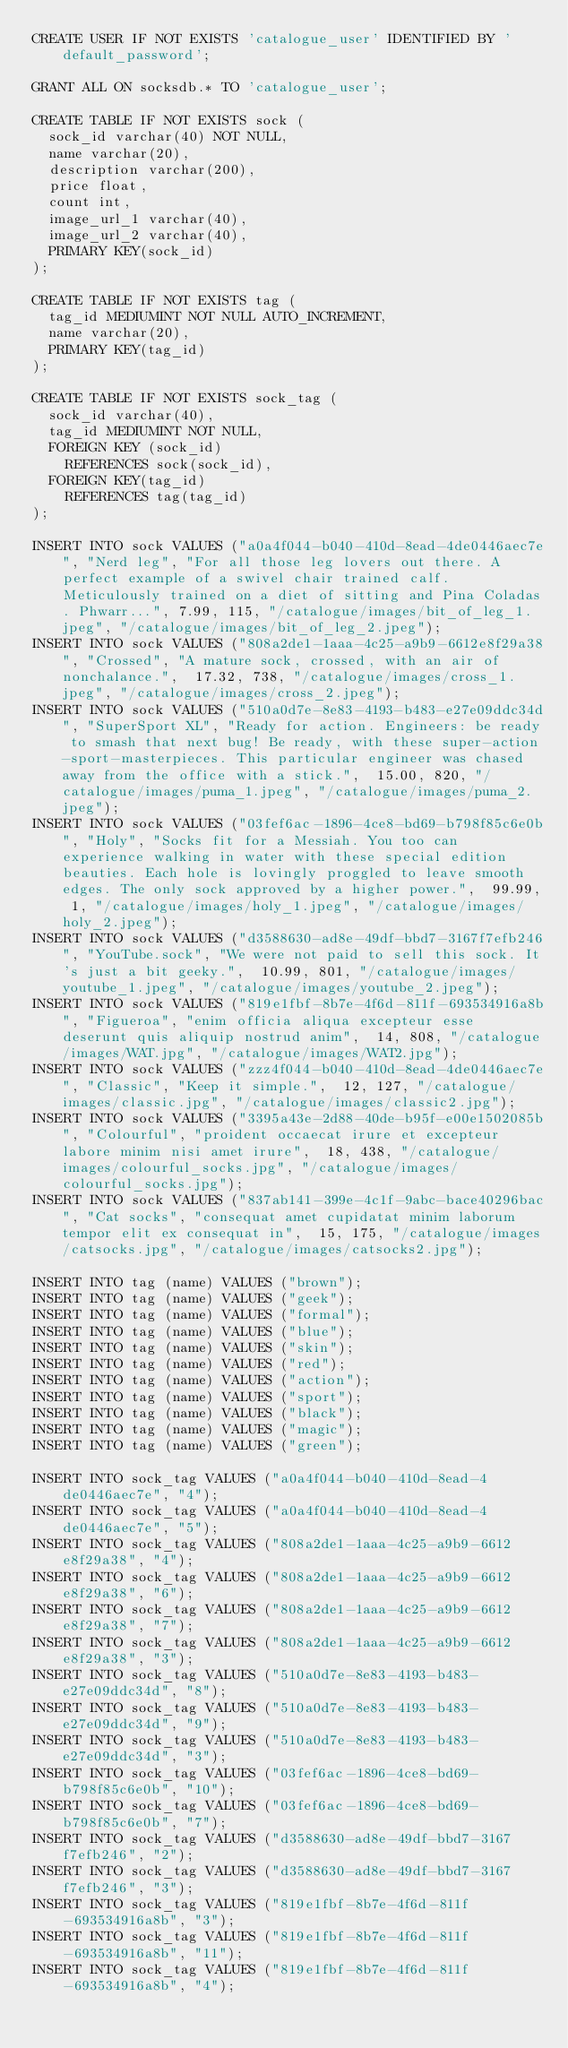<code> <loc_0><loc_0><loc_500><loc_500><_SQL_>CREATE USER IF NOT EXISTS 'catalogue_user' IDENTIFIED BY 'default_password';

GRANT ALL ON socksdb.* TO 'catalogue_user';

CREATE TABLE IF NOT EXISTS sock (
	sock_id varchar(40) NOT NULL, 
	name varchar(20), 
	description varchar(200), 
	price float, 
	count int, 
	image_url_1 varchar(40), 
	image_url_2 varchar(40), 
	PRIMARY KEY(sock_id)
);

CREATE TABLE IF NOT EXISTS tag (
	tag_id MEDIUMINT NOT NULL AUTO_INCREMENT, 
	name varchar(20), 
	PRIMARY KEY(tag_id)
);

CREATE TABLE IF NOT EXISTS sock_tag (
	sock_id varchar(40), 
	tag_id MEDIUMINT NOT NULL, 
	FOREIGN KEY (sock_id) 
		REFERENCES sock(sock_id), 
	FOREIGN KEY(tag_id)
		REFERENCES tag(tag_id)
);

INSERT INTO sock VALUES ("a0a4f044-b040-410d-8ead-4de0446aec7e", "Nerd leg", "For all those leg lovers out there. A perfect example of a swivel chair trained calf. Meticulously trained on a diet of sitting and Pina Coladas. Phwarr...", 7.99, 115, "/catalogue/images/bit_of_leg_1.jpeg", "/catalogue/images/bit_of_leg_2.jpeg");
INSERT INTO sock VALUES ("808a2de1-1aaa-4c25-a9b9-6612e8f29a38", "Crossed", "A mature sock, crossed, with an air of nonchalance.",  17.32, 738, "/catalogue/images/cross_1.jpeg", "/catalogue/images/cross_2.jpeg");
INSERT INTO sock VALUES ("510a0d7e-8e83-4193-b483-e27e09ddc34d", "SuperSport XL", "Ready for action. Engineers: be ready to smash that next bug! Be ready, with these super-action-sport-masterpieces. This particular engineer was chased away from the office with a stick.",  15.00, 820, "/catalogue/images/puma_1.jpeg", "/catalogue/images/puma_2.jpeg");
INSERT INTO sock VALUES ("03fef6ac-1896-4ce8-bd69-b798f85c6e0b", "Holy", "Socks fit for a Messiah. You too can experience walking in water with these special edition beauties. Each hole is lovingly proggled to leave smooth edges. The only sock approved by a higher power.",  99.99, 1, "/catalogue/images/holy_1.jpeg", "/catalogue/images/holy_2.jpeg");
INSERT INTO sock VALUES ("d3588630-ad8e-49df-bbd7-3167f7efb246", "YouTube.sock", "We were not paid to sell this sock. It's just a bit geeky.",  10.99, 801, "/catalogue/images/youtube_1.jpeg", "/catalogue/images/youtube_2.jpeg");
INSERT INTO sock VALUES ("819e1fbf-8b7e-4f6d-811f-693534916a8b", "Figueroa", "enim officia aliqua excepteur esse deserunt quis aliquip nostrud anim",  14, 808, "/catalogue/images/WAT.jpg", "/catalogue/images/WAT2.jpg");
INSERT INTO sock VALUES ("zzz4f044-b040-410d-8ead-4de0446aec7e", "Classic", "Keep it simple.",  12, 127, "/catalogue/images/classic.jpg", "/catalogue/images/classic2.jpg");
INSERT INTO sock VALUES ("3395a43e-2d88-40de-b95f-e00e1502085b", "Colourful", "proident occaecat irure et excepteur labore minim nisi amet irure",  18, 438, "/catalogue/images/colourful_socks.jpg", "/catalogue/images/colourful_socks.jpg");
INSERT INTO sock VALUES ("837ab141-399e-4c1f-9abc-bace40296bac", "Cat socks", "consequat amet cupidatat minim laborum tempor elit ex consequat in",  15, 175, "/catalogue/images/catsocks.jpg", "/catalogue/images/catsocks2.jpg");

INSERT INTO tag (name) VALUES ("brown");
INSERT INTO tag (name) VALUES ("geek");
INSERT INTO tag (name) VALUES ("formal");
INSERT INTO tag (name) VALUES ("blue");
INSERT INTO tag (name) VALUES ("skin");
INSERT INTO tag (name) VALUES ("red");
INSERT INTO tag (name) VALUES ("action");
INSERT INTO tag (name) VALUES ("sport");
INSERT INTO tag (name) VALUES ("black");
INSERT INTO tag (name) VALUES ("magic");
INSERT INTO tag (name) VALUES ("green");

INSERT INTO sock_tag VALUES ("a0a4f044-b040-410d-8ead-4de0446aec7e", "4");
INSERT INTO sock_tag VALUES ("a0a4f044-b040-410d-8ead-4de0446aec7e", "5");
INSERT INTO sock_tag VALUES ("808a2de1-1aaa-4c25-a9b9-6612e8f29a38", "4");
INSERT INTO sock_tag VALUES ("808a2de1-1aaa-4c25-a9b9-6612e8f29a38", "6");
INSERT INTO sock_tag VALUES ("808a2de1-1aaa-4c25-a9b9-6612e8f29a38", "7");
INSERT INTO sock_tag VALUES ("808a2de1-1aaa-4c25-a9b9-6612e8f29a38", "3");
INSERT INTO sock_tag VALUES ("510a0d7e-8e83-4193-b483-e27e09ddc34d", "8");
INSERT INTO sock_tag VALUES ("510a0d7e-8e83-4193-b483-e27e09ddc34d", "9");
INSERT INTO sock_tag VALUES ("510a0d7e-8e83-4193-b483-e27e09ddc34d", "3");
INSERT INTO sock_tag VALUES ("03fef6ac-1896-4ce8-bd69-b798f85c6e0b", "10");
INSERT INTO sock_tag VALUES ("03fef6ac-1896-4ce8-bd69-b798f85c6e0b", "7");
INSERT INTO sock_tag VALUES ("d3588630-ad8e-49df-bbd7-3167f7efb246", "2");
INSERT INTO sock_tag VALUES ("d3588630-ad8e-49df-bbd7-3167f7efb246", "3");
INSERT INTO sock_tag VALUES ("819e1fbf-8b7e-4f6d-811f-693534916a8b", "3");
INSERT INTO sock_tag VALUES ("819e1fbf-8b7e-4f6d-811f-693534916a8b", "11");
INSERT INTO sock_tag VALUES ("819e1fbf-8b7e-4f6d-811f-693534916a8b", "4");</code> 